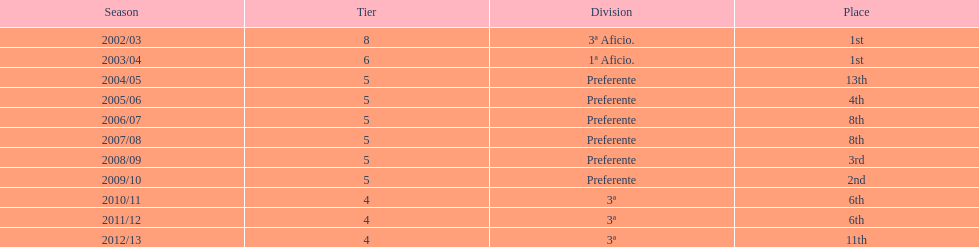In which year did the squad attain the identical position as 2010/11? 2011/12. 